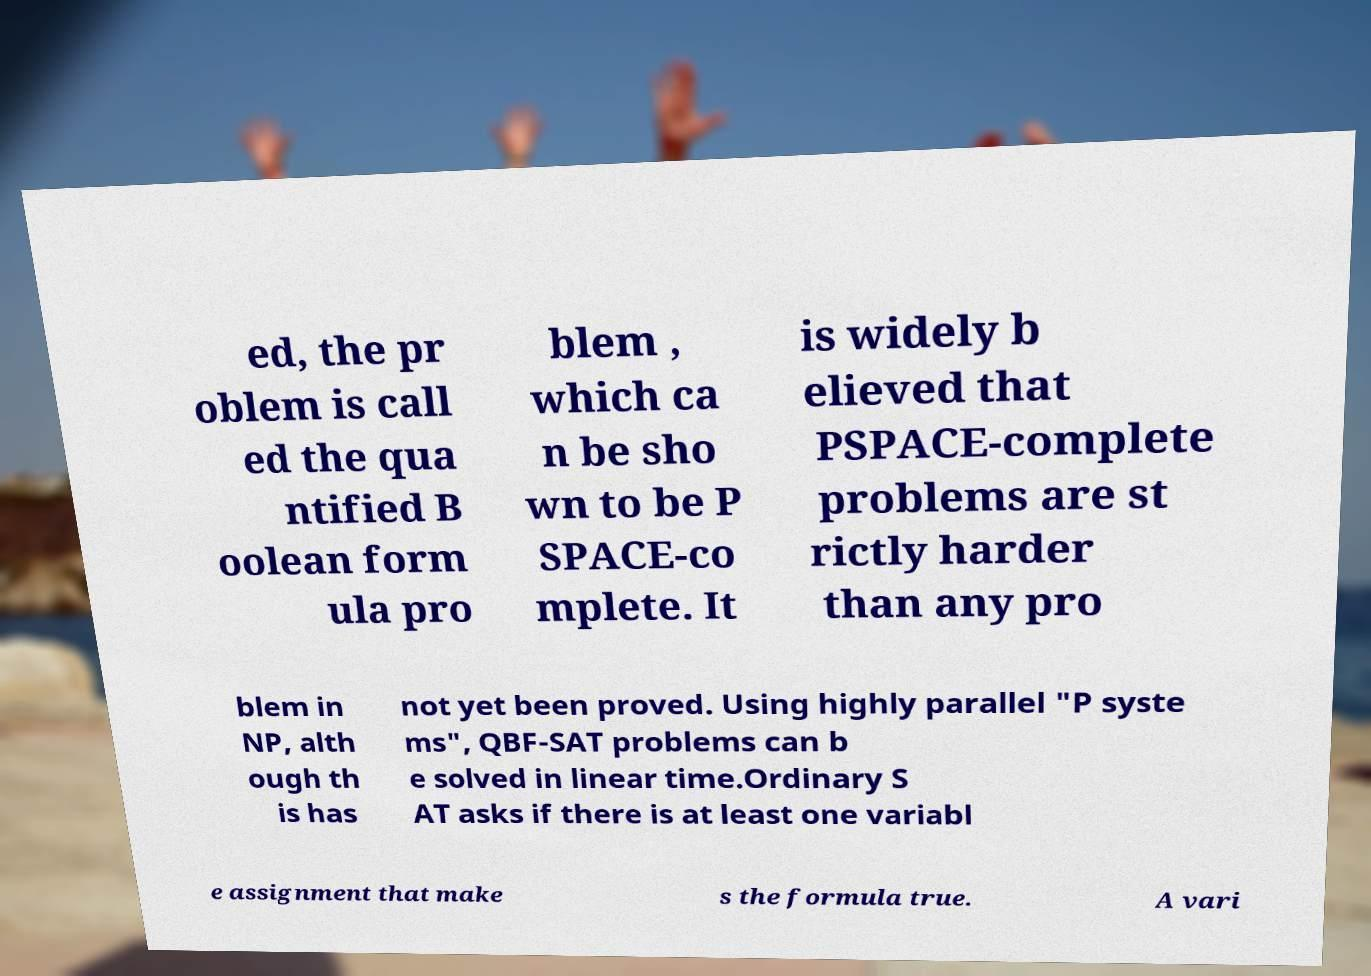Could you assist in decoding the text presented in this image and type it out clearly? ed, the pr oblem is call ed the qua ntified B oolean form ula pro blem , which ca n be sho wn to be P SPACE-co mplete. It is widely b elieved that PSPACE-complete problems are st rictly harder than any pro blem in NP, alth ough th is has not yet been proved. Using highly parallel "P syste ms", QBF-SAT problems can b e solved in linear time.Ordinary S AT asks if there is at least one variabl e assignment that make s the formula true. A vari 